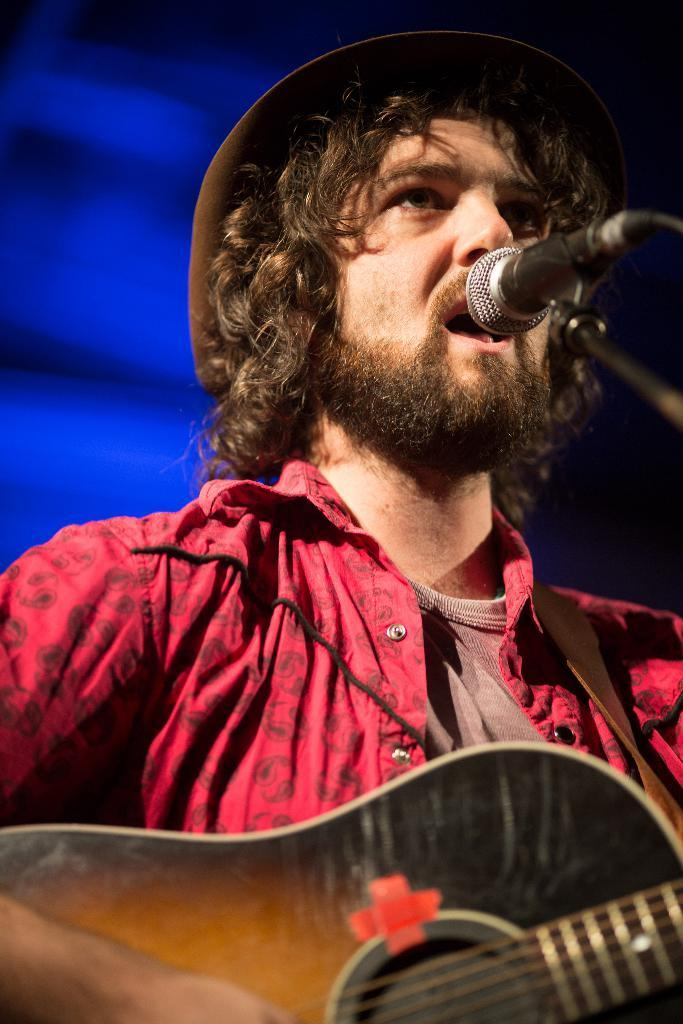What is the man in the image doing? The man is singing and playing a guitar. What is the man wearing on his head? The man is wearing a hat. What color is the shirt the man is wearing? The man is wearing a red shirt. What object is in front of the man? There is a microphone in front of the man. What can be seen in the background of the image? There is a blue curtain in the background. What type of beef is being cut with a knife in the image? There is no beef or knife present in the image; it features a man singing and playing a guitar. What brand of toothpaste is the man using in the image? There is no toothpaste present in the image; it features a man singing and playing a guitar. 